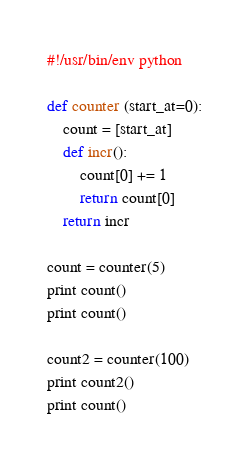<code> <loc_0><loc_0><loc_500><loc_500><_Python_>#!/usr/bin/env python

def counter (start_at=0):
	count = [start_at]
	def incr():
		count[0] += 1
		return count[0]
	return incr

count = counter(5)
print count()
print count()

count2 = counter(100)
print count2()
print count()
</code> 